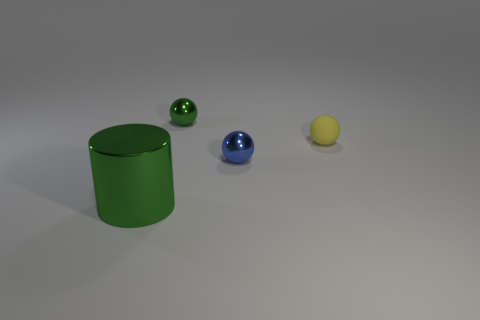How many tiny green things are the same shape as the small yellow matte thing?
Offer a very short reply. 1. Are the small yellow object and the green thing that is on the left side of the small green sphere made of the same material?
Give a very brief answer. No. Is the number of yellow rubber things that are in front of the big green metallic cylinder greater than the number of spheres?
Give a very brief answer. No. What shape is the tiny shiny object that is the same color as the cylinder?
Make the answer very short. Sphere. Are there any brown things that have the same material as the tiny yellow thing?
Give a very brief answer. No. Are the small sphere left of the tiny blue sphere and the object that is on the left side of the tiny green ball made of the same material?
Your response must be concise. Yes. Are there the same number of green metallic things right of the small green metal object and tiny objects that are behind the tiny yellow rubber sphere?
Offer a terse response. No. What color is the matte sphere that is the same size as the blue metal ball?
Ensure brevity in your answer.  Yellow. Are there any metal cylinders that have the same color as the large metallic object?
Offer a terse response. No. How many things are either shiny objects that are behind the small rubber object or big gray blocks?
Your answer should be very brief. 1. 